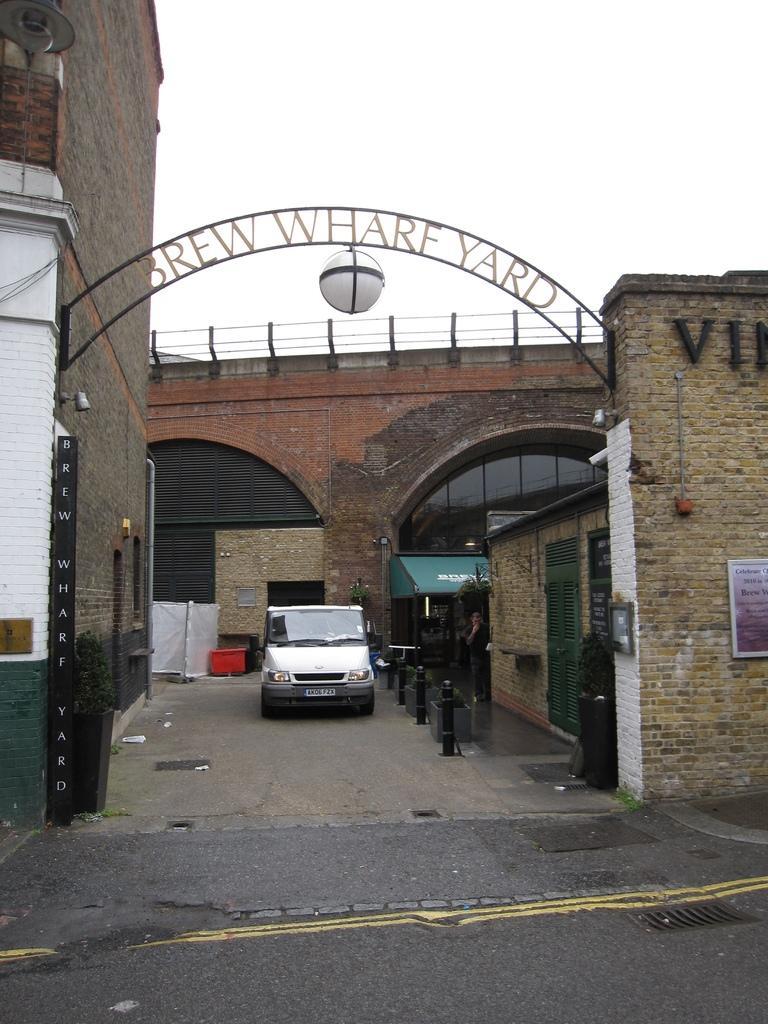Can you describe this image briefly? In this picture we can see a car on the road and in the background we can see a building,sky. 